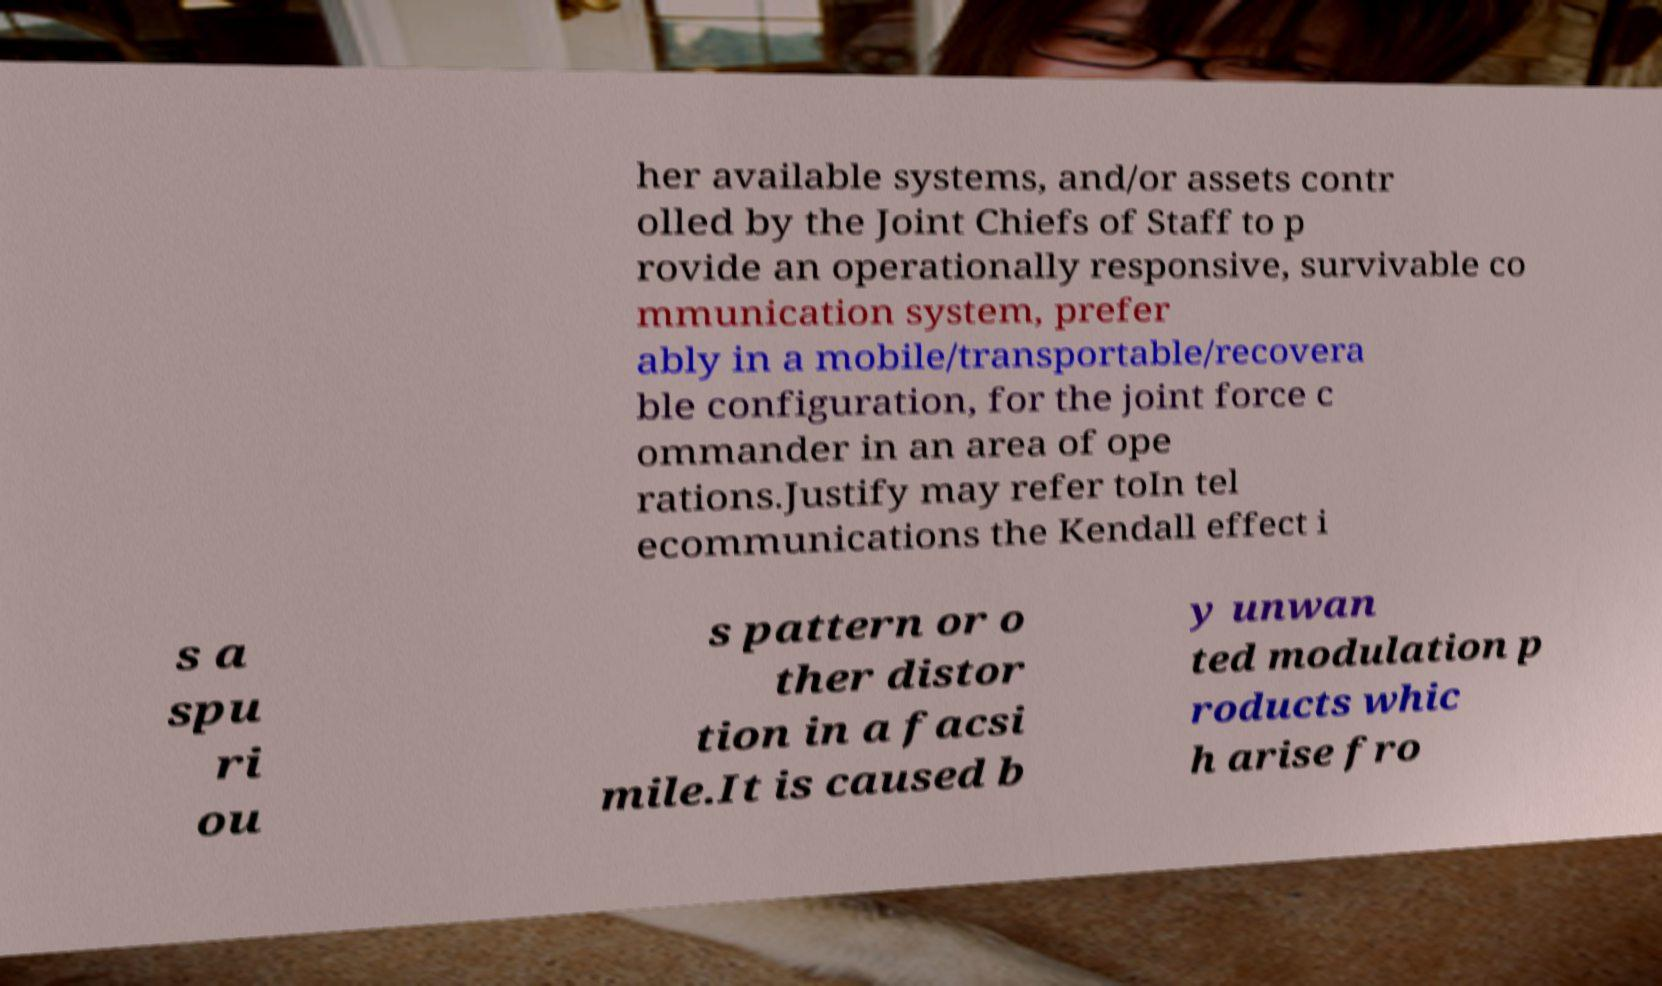For documentation purposes, I need the text within this image transcribed. Could you provide that? her available systems, and/or assets contr olled by the Joint Chiefs of Staff to p rovide an operationally responsive, survivable co mmunication system, prefer ably in a mobile/transportable/recovera ble configuration, for the joint force c ommander in an area of ope rations.Justify may refer toIn tel ecommunications the Kendall effect i s a spu ri ou s pattern or o ther distor tion in a facsi mile.It is caused b y unwan ted modulation p roducts whic h arise fro 